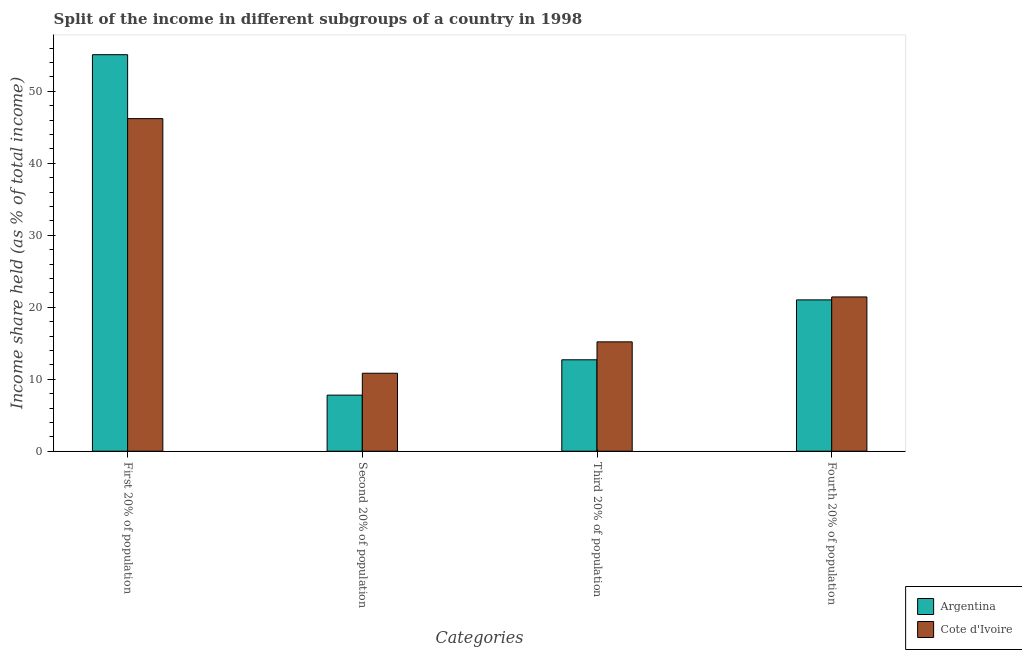How many different coloured bars are there?
Make the answer very short. 2. How many groups of bars are there?
Keep it short and to the point. 4. Are the number of bars on each tick of the X-axis equal?
Offer a terse response. Yes. How many bars are there on the 4th tick from the left?
Your answer should be very brief. 2. What is the label of the 3rd group of bars from the left?
Provide a short and direct response. Third 20% of population. What is the share of the income held by first 20% of the population in Cote d'Ivoire?
Your answer should be compact. 46.2. Across all countries, what is the maximum share of the income held by fourth 20% of the population?
Your response must be concise. 21.43. In which country was the share of the income held by fourth 20% of the population maximum?
Offer a terse response. Cote d'Ivoire. What is the total share of the income held by second 20% of the population in the graph?
Provide a short and direct response. 18.62. What is the difference between the share of the income held by fourth 20% of the population in Cote d'Ivoire and that in Argentina?
Your response must be concise. 0.41. What is the difference between the share of the income held by first 20% of the population in Argentina and the share of the income held by third 20% of the population in Cote d'Ivoire?
Your response must be concise. 39.89. What is the average share of the income held by third 20% of the population per country?
Keep it short and to the point. 13.95. What is the difference between the share of the income held by second 20% of the population and share of the income held by fourth 20% of the population in Argentina?
Provide a short and direct response. -13.23. What is the ratio of the share of the income held by first 20% of the population in Argentina to that in Cote d'Ivoire?
Keep it short and to the point. 1.19. Is the difference between the share of the income held by second 20% of the population in Argentina and Cote d'Ivoire greater than the difference between the share of the income held by first 20% of the population in Argentina and Cote d'Ivoire?
Your answer should be compact. No. What is the difference between the highest and the second highest share of the income held by first 20% of the population?
Offer a terse response. 8.88. What is the difference between the highest and the lowest share of the income held by fourth 20% of the population?
Provide a short and direct response. 0.41. What does the 2nd bar from the left in Fourth 20% of population represents?
Your answer should be very brief. Cote d'Ivoire. What does the 2nd bar from the right in Fourth 20% of population represents?
Ensure brevity in your answer.  Argentina. Is it the case that in every country, the sum of the share of the income held by first 20% of the population and share of the income held by second 20% of the population is greater than the share of the income held by third 20% of the population?
Your answer should be compact. Yes. How many bars are there?
Offer a very short reply. 8. Are all the bars in the graph horizontal?
Make the answer very short. No. How many countries are there in the graph?
Offer a very short reply. 2. What is the difference between two consecutive major ticks on the Y-axis?
Offer a very short reply. 10. Does the graph contain grids?
Ensure brevity in your answer.  No. Where does the legend appear in the graph?
Make the answer very short. Bottom right. How are the legend labels stacked?
Provide a short and direct response. Vertical. What is the title of the graph?
Make the answer very short. Split of the income in different subgroups of a country in 1998. Does "Ecuador" appear as one of the legend labels in the graph?
Your response must be concise. No. What is the label or title of the X-axis?
Give a very brief answer. Categories. What is the label or title of the Y-axis?
Provide a succinct answer. Income share held (as % of total income). What is the Income share held (as % of total income) of Argentina in First 20% of population?
Your response must be concise. 55.08. What is the Income share held (as % of total income) in Cote d'Ivoire in First 20% of population?
Your response must be concise. 46.2. What is the Income share held (as % of total income) in Argentina in Second 20% of population?
Keep it short and to the point. 7.79. What is the Income share held (as % of total income) in Cote d'Ivoire in Second 20% of population?
Make the answer very short. 10.83. What is the Income share held (as % of total income) of Argentina in Third 20% of population?
Provide a succinct answer. 12.7. What is the Income share held (as % of total income) of Cote d'Ivoire in Third 20% of population?
Ensure brevity in your answer.  15.19. What is the Income share held (as % of total income) of Argentina in Fourth 20% of population?
Provide a short and direct response. 21.02. What is the Income share held (as % of total income) of Cote d'Ivoire in Fourth 20% of population?
Provide a short and direct response. 21.43. Across all Categories, what is the maximum Income share held (as % of total income) in Argentina?
Offer a very short reply. 55.08. Across all Categories, what is the maximum Income share held (as % of total income) in Cote d'Ivoire?
Provide a short and direct response. 46.2. Across all Categories, what is the minimum Income share held (as % of total income) in Argentina?
Offer a very short reply. 7.79. Across all Categories, what is the minimum Income share held (as % of total income) in Cote d'Ivoire?
Give a very brief answer. 10.83. What is the total Income share held (as % of total income) of Argentina in the graph?
Ensure brevity in your answer.  96.59. What is the total Income share held (as % of total income) in Cote d'Ivoire in the graph?
Make the answer very short. 93.65. What is the difference between the Income share held (as % of total income) in Argentina in First 20% of population and that in Second 20% of population?
Offer a very short reply. 47.29. What is the difference between the Income share held (as % of total income) of Cote d'Ivoire in First 20% of population and that in Second 20% of population?
Your answer should be very brief. 35.37. What is the difference between the Income share held (as % of total income) in Argentina in First 20% of population and that in Third 20% of population?
Provide a succinct answer. 42.38. What is the difference between the Income share held (as % of total income) of Cote d'Ivoire in First 20% of population and that in Third 20% of population?
Provide a succinct answer. 31.01. What is the difference between the Income share held (as % of total income) of Argentina in First 20% of population and that in Fourth 20% of population?
Keep it short and to the point. 34.06. What is the difference between the Income share held (as % of total income) of Cote d'Ivoire in First 20% of population and that in Fourth 20% of population?
Your answer should be compact. 24.77. What is the difference between the Income share held (as % of total income) in Argentina in Second 20% of population and that in Third 20% of population?
Your response must be concise. -4.91. What is the difference between the Income share held (as % of total income) of Cote d'Ivoire in Second 20% of population and that in Third 20% of population?
Your response must be concise. -4.36. What is the difference between the Income share held (as % of total income) in Argentina in Second 20% of population and that in Fourth 20% of population?
Keep it short and to the point. -13.23. What is the difference between the Income share held (as % of total income) in Cote d'Ivoire in Second 20% of population and that in Fourth 20% of population?
Offer a very short reply. -10.6. What is the difference between the Income share held (as % of total income) in Argentina in Third 20% of population and that in Fourth 20% of population?
Ensure brevity in your answer.  -8.32. What is the difference between the Income share held (as % of total income) in Cote d'Ivoire in Third 20% of population and that in Fourth 20% of population?
Your answer should be very brief. -6.24. What is the difference between the Income share held (as % of total income) of Argentina in First 20% of population and the Income share held (as % of total income) of Cote d'Ivoire in Second 20% of population?
Ensure brevity in your answer.  44.25. What is the difference between the Income share held (as % of total income) of Argentina in First 20% of population and the Income share held (as % of total income) of Cote d'Ivoire in Third 20% of population?
Make the answer very short. 39.89. What is the difference between the Income share held (as % of total income) in Argentina in First 20% of population and the Income share held (as % of total income) in Cote d'Ivoire in Fourth 20% of population?
Offer a terse response. 33.65. What is the difference between the Income share held (as % of total income) in Argentina in Second 20% of population and the Income share held (as % of total income) in Cote d'Ivoire in Third 20% of population?
Ensure brevity in your answer.  -7.4. What is the difference between the Income share held (as % of total income) in Argentina in Second 20% of population and the Income share held (as % of total income) in Cote d'Ivoire in Fourth 20% of population?
Your answer should be compact. -13.64. What is the difference between the Income share held (as % of total income) of Argentina in Third 20% of population and the Income share held (as % of total income) of Cote d'Ivoire in Fourth 20% of population?
Your answer should be very brief. -8.73. What is the average Income share held (as % of total income) in Argentina per Categories?
Keep it short and to the point. 24.15. What is the average Income share held (as % of total income) in Cote d'Ivoire per Categories?
Give a very brief answer. 23.41. What is the difference between the Income share held (as % of total income) of Argentina and Income share held (as % of total income) of Cote d'Ivoire in First 20% of population?
Offer a very short reply. 8.88. What is the difference between the Income share held (as % of total income) of Argentina and Income share held (as % of total income) of Cote d'Ivoire in Second 20% of population?
Provide a short and direct response. -3.04. What is the difference between the Income share held (as % of total income) in Argentina and Income share held (as % of total income) in Cote d'Ivoire in Third 20% of population?
Give a very brief answer. -2.49. What is the difference between the Income share held (as % of total income) of Argentina and Income share held (as % of total income) of Cote d'Ivoire in Fourth 20% of population?
Your answer should be compact. -0.41. What is the ratio of the Income share held (as % of total income) of Argentina in First 20% of population to that in Second 20% of population?
Provide a succinct answer. 7.07. What is the ratio of the Income share held (as % of total income) in Cote d'Ivoire in First 20% of population to that in Second 20% of population?
Provide a succinct answer. 4.27. What is the ratio of the Income share held (as % of total income) of Argentina in First 20% of population to that in Third 20% of population?
Give a very brief answer. 4.34. What is the ratio of the Income share held (as % of total income) of Cote d'Ivoire in First 20% of population to that in Third 20% of population?
Offer a terse response. 3.04. What is the ratio of the Income share held (as % of total income) of Argentina in First 20% of population to that in Fourth 20% of population?
Provide a short and direct response. 2.62. What is the ratio of the Income share held (as % of total income) in Cote d'Ivoire in First 20% of population to that in Fourth 20% of population?
Keep it short and to the point. 2.16. What is the ratio of the Income share held (as % of total income) in Argentina in Second 20% of population to that in Third 20% of population?
Give a very brief answer. 0.61. What is the ratio of the Income share held (as % of total income) in Cote d'Ivoire in Second 20% of population to that in Third 20% of population?
Give a very brief answer. 0.71. What is the ratio of the Income share held (as % of total income) of Argentina in Second 20% of population to that in Fourth 20% of population?
Provide a short and direct response. 0.37. What is the ratio of the Income share held (as % of total income) in Cote d'Ivoire in Second 20% of population to that in Fourth 20% of population?
Keep it short and to the point. 0.51. What is the ratio of the Income share held (as % of total income) of Argentina in Third 20% of population to that in Fourth 20% of population?
Provide a succinct answer. 0.6. What is the ratio of the Income share held (as % of total income) of Cote d'Ivoire in Third 20% of population to that in Fourth 20% of population?
Offer a very short reply. 0.71. What is the difference between the highest and the second highest Income share held (as % of total income) in Argentina?
Ensure brevity in your answer.  34.06. What is the difference between the highest and the second highest Income share held (as % of total income) of Cote d'Ivoire?
Offer a terse response. 24.77. What is the difference between the highest and the lowest Income share held (as % of total income) of Argentina?
Keep it short and to the point. 47.29. What is the difference between the highest and the lowest Income share held (as % of total income) of Cote d'Ivoire?
Your answer should be very brief. 35.37. 